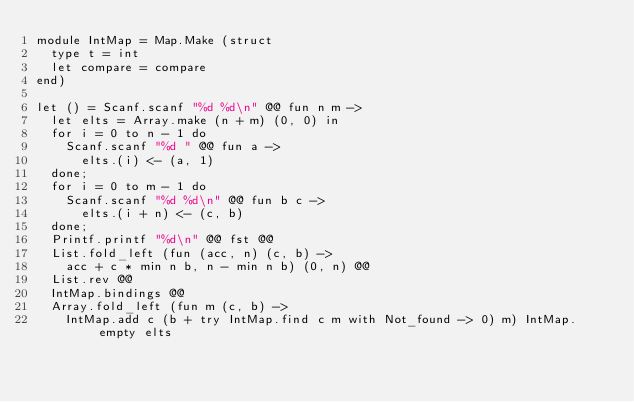Convert code to text. <code><loc_0><loc_0><loc_500><loc_500><_OCaml_>module IntMap = Map.Make (struct
  type t = int
  let compare = compare
end)

let () = Scanf.scanf "%d %d\n" @@ fun n m ->
  let elts = Array.make (n + m) (0, 0) in
  for i = 0 to n - 1 do
    Scanf.scanf "%d " @@ fun a ->
      elts.(i) <- (a, 1)
  done;
  for i = 0 to m - 1 do
    Scanf.scanf "%d %d\n" @@ fun b c ->
      elts.(i + n) <- (c, b)
  done;
  Printf.printf "%d\n" @@ fst @@
  List.fold_left (fun (acc, n) (c, b) ->
    acc + c * min n b, n - min n b) (0, n) @@
  List.rev @@
  IntMap.bindings @@
  Array.fold_left (fun m (c, b) ->
    IntMap.add c (b + try IntMap.find c m with Not_found -> 0) m) IntMap.empty elts</code> 